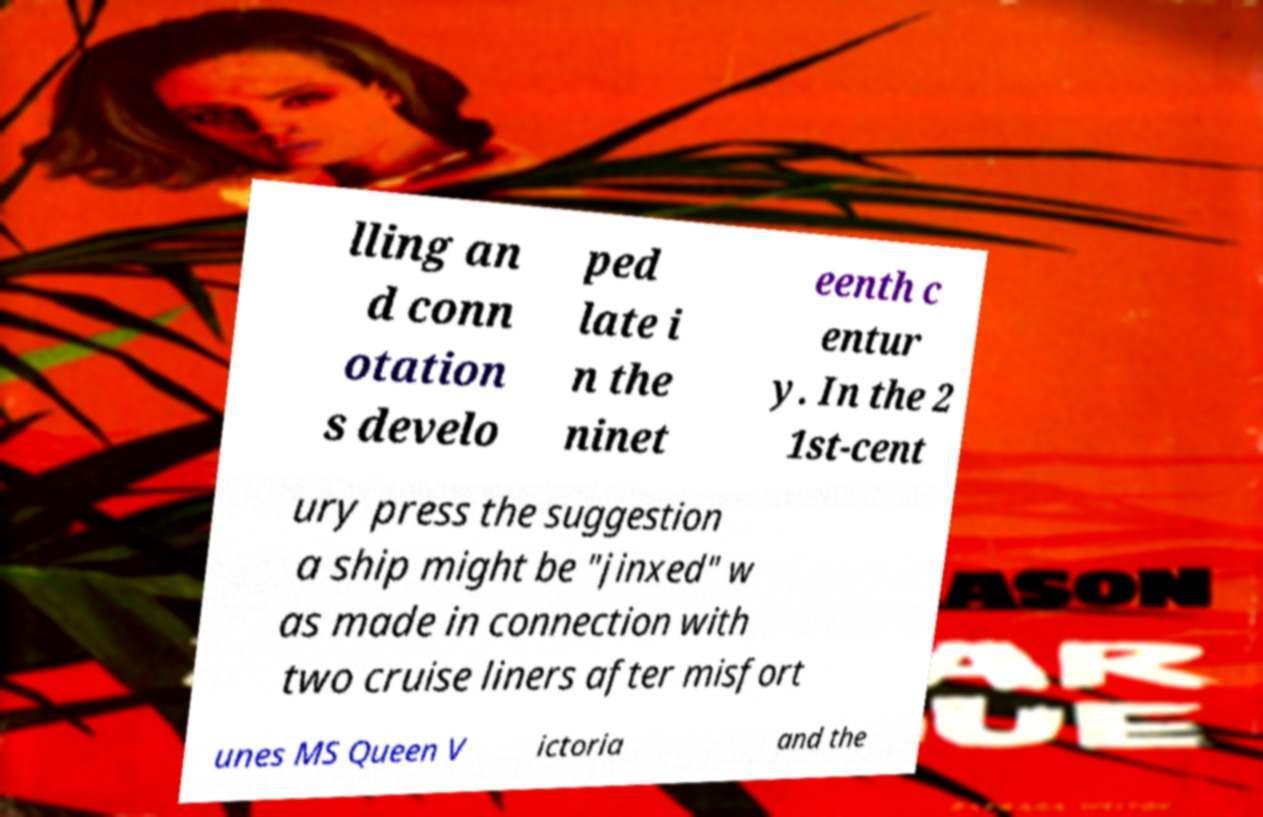Please read and relay the text visible in this image. What does it say? lling an d conn otation s develo ped late i n the ninet eenth c entur y. In the 2 1st-cent ury press the suggestion a ship might be "jinxed" w as made in connection with two cruise liners after misfort unes MS Queen V ictoria and the 